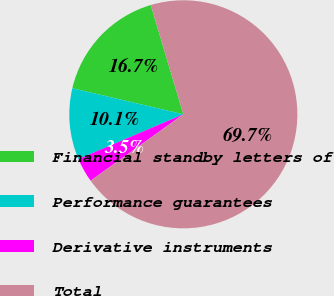Convert chart to OTSL. <chart><loc_0><loc_0><loc_500><loc_500><pie_chart><fcel>Financial standby letters of<fcel>Performance guarantees<fcel>Derivative instruments<fcel>Total<nl><fcel>16.72%<fcel>10.09%<fcel>3.47%<fcel>69.73%<nl></chart> 